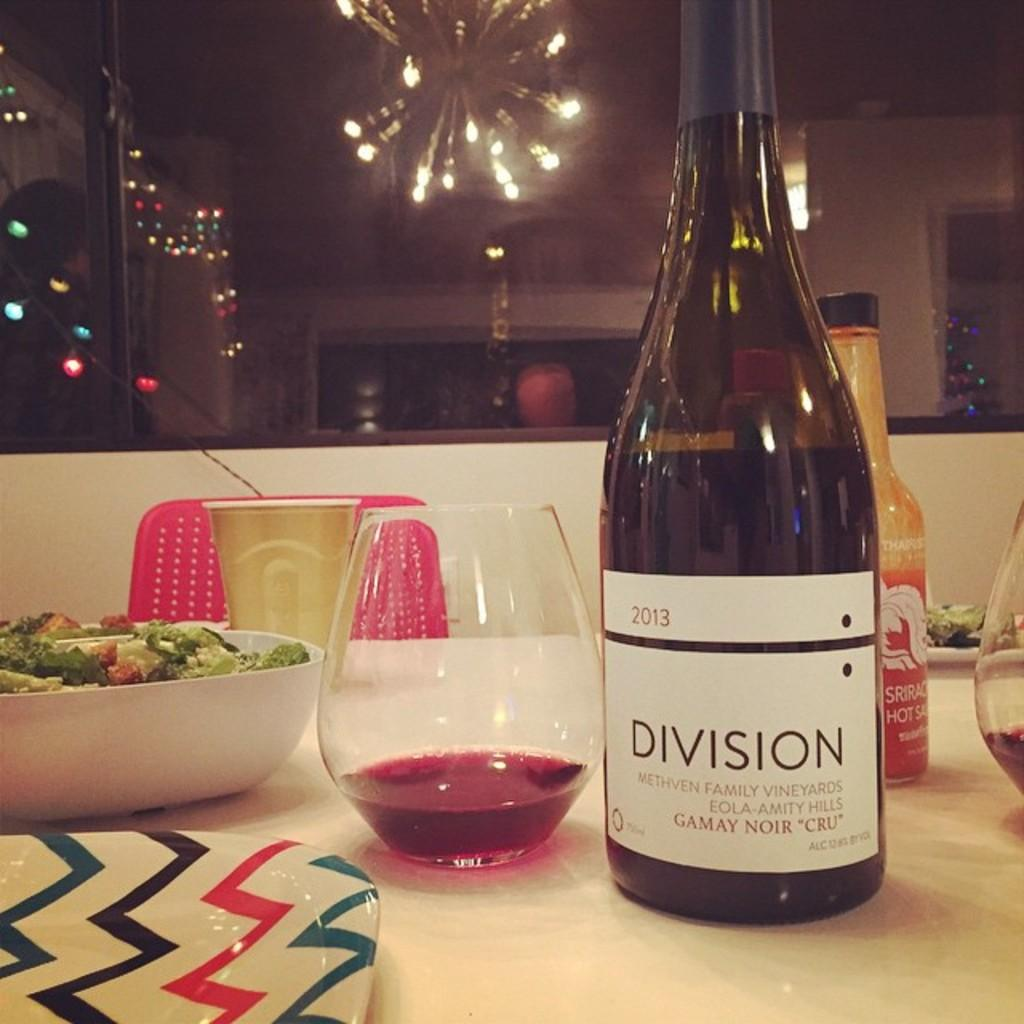What type of beverage container is in the image? There is a wine bottle in the image. What is another object in the image that is typically used for drinking? There is a glass in the image. What is the third object in the image that is typically used for holding food or liquids? There is a bowl in the image. What is the fourth object in the image that is typically used for holding food? There is a plate in the image. Where are all these objects located? All objects are on a table. What type of net is being used in the image? There is no net present in the image. What type of experience is the person having in the image? The image does not depict a person or any experience they might be having. 